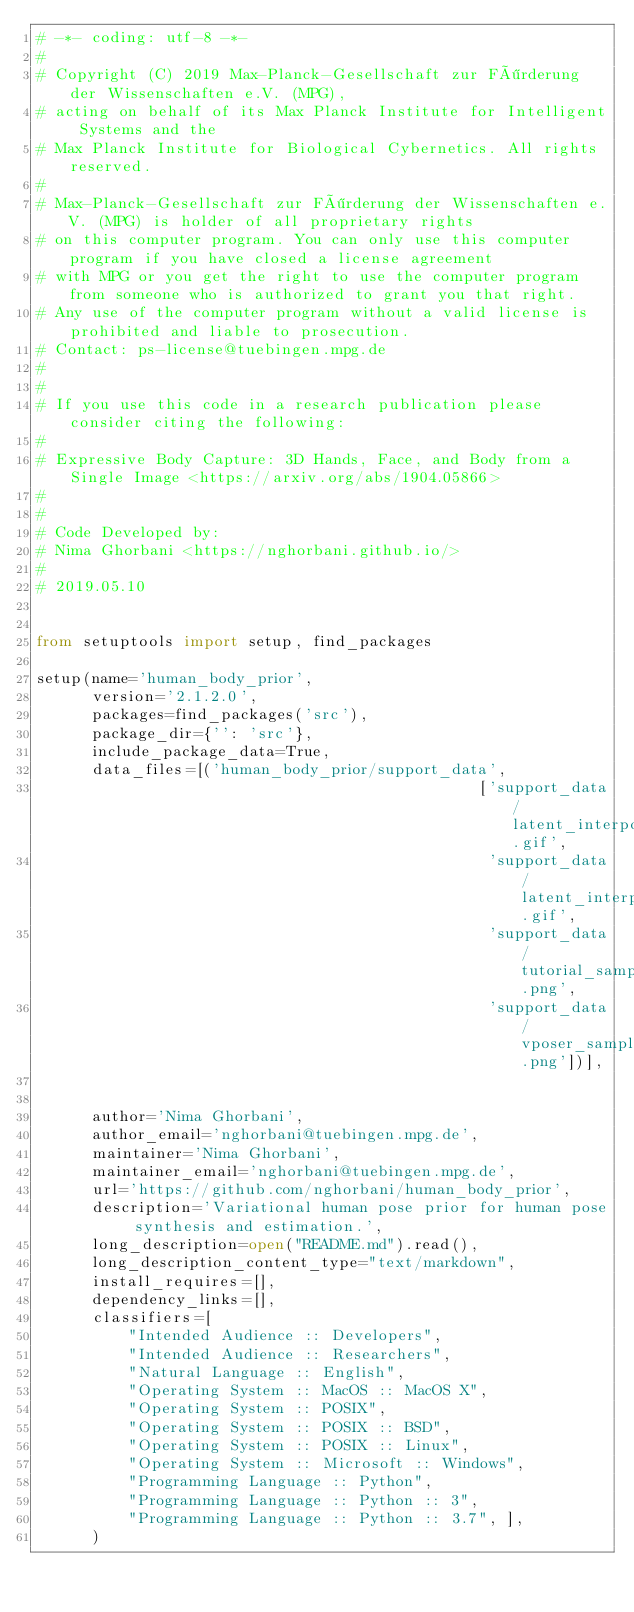Convert code to text. <code><loc_0><loc_0><loc_500><loc_500><_Python_># -*- coding: utf-8 -*-
#
# Copyright (C) 2019 Max-Planck-Gesellschaft zur Förderung der Wissenschaften e.V. (MPG),
# acting on behalf of its Max Planck Institute for Intelligent Systems and the
# Max Planck Institute for Biological Cybernetics. All rights reserved.
#
# Max-Planck-Gesellschaft zur Förderung der Wissenschaften e.V. (MPG) is holder of all proprietary rights
# on this computer program. You can only use this computer program if you have closed a license agreement
# with MPG or you get the right to use the computer program from someone who is authorized to grant you that right.
# Any use of the computer program without a valid license is prohibited and liable to prosecution.
# Contact: ps-license@tuebingen.mpg.de
#
#
# If you use this code in a research publication please consider citing the following:
#
# Expressive Body Capture: 3D Hands, Face, and Body from a Single Image <https://arxiv.org/abs/1904.05866>
#
#
# Code Developed by:
# Nima Ghorbani <https://nghorbani.github.io/>
#
# 2019.05.10


from setuptools import setup, find_packages

setup(name='human_body_prior',
      version='2.1.2.0',
      packages=find_packages('src'),
      package_dir={'': 'src'},
      include_package_data=True,
      data_files=[('human_body_prior/support_data', 
                                                ['support_data/latent_interpolation_1.gif',
                                                 'support_data/latent_interpolation_2.gif', 
                                                 'support_data/tutorial_sample_body_pose.png', 
                                                 'support_data/vposer_samples.png'])],


      author='Nima Ghorbani',
      author_email='nghorbani@tuebingen.mpg.de',
      maintainer='Nima Ghorbani',
      maintainer_email='nghorbani@tuebingen.mpg.de',
      url='https://github.com/nghorbani/human_body_prior',
      description='Variational human pose prior for human pose synthesis and estimation.',
      long_description=open("README.md").read(),
      long_description_content_type="text/markdown",
      install_requires=[],
      dependency_links=[],
      classifiers=[
          "Intended Audience :: Developers",
          "Intended Audience :: Researchers",
          "Natural Language :: English",
          "Operating System :: MacOS :: MacOS X",
          "Operating System :: POSIX",
          "Operating System :: POSIX :: BSD",
          "Operating System :: POSIX :: Linux",
          "Operating System :: Microsoft :: Windows",
          "Programming Language :: Python",
          "Programming Language :: Python :: 3",
          "Programming Language :: Python :: 3.7", ],
      )
</code> 